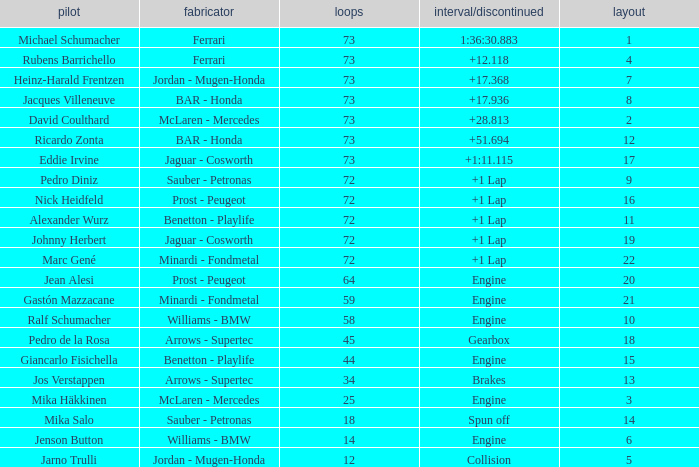Would you mind parsing the complete table? {'header': ['pilot', 'fabricator', 'loops', 'interval/discontinued', 'layout'], 'rows': [['Michael Schumacher', 'Ferrari', '73', '1:36:30.883', '1'], ['Rubens Barrichello', 'Ferrari', '73', '+12.118', '4'], ['Heinz-Harald Frentzen', 'Jordan - Mugen-Honda', '73', '+17.368', '7'], ['Jacques Villeneuve', 'BAR - Honda', '73', '+17.936', '8'], ['David Coulthard', 'McLaren - Mercedes', '73', '+28.813', '2'], ['Ricardo Zonta', 'BAR - Honda', '73', '+51.694', '12'], ['Eddie Irvine', 'Jaguar - Cosworth', '73', '+1:11.115', '17'], ['Pedro Diniz', 'Sauber - Petronas', '72', '+1 Lap', '9'], ['Nick Heidfeld', 'Prost - Peugeot', '72', '+1 Lap', '16'], ['Alexander Wurz', 'Benetton - Playlife', '72', '+1 Lap', '11'], ['Johnny Herbert', 'Jaguar - Cosworth', '72', '+1 Lap', '19'], ['Marc Gené', 'Minardi - Fondmetal', '72', '+1 Lap', '22'], ['Jean Alesi', 'Prost - Peugeot', '64', 'Engine', '20'], ['Gastón Mazzacane', 'Minardi - Fondmetal', '59', 'Engine', '21'], ['Ralf Schumacher', 'Williams - BMW', '58', 'Engine', '10'], ['Pedro de la Rosa', 'Arrows - Supertec', '45', 'Gearbox', '18'], ['Giancarlo Fisichella', 'Benetton - Playlife', '44', 'Engine', '15'], ['Jos Verstappen', 'Arrows - Supertec', '34', 'Brakes', '13'], ['Mika Häkkinen', 'McLaren - Mercedes', '25', 'Engine', '3'], ['Mika Salo', 'Sauber - Petronas', '18', 'Spun off', '14'], ['Jenson Button', 'Williams - BMW', '14', 'Engine', '6'], ['Jarno Trulli', 'Jordan - Mugen-Honda', '12', 'Collision', '5']]} How many laps did Jos Verstappen do on Grid 2? 34.0. 